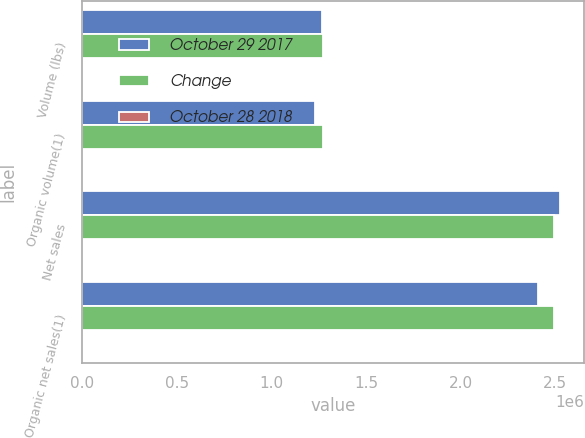<chart> <loc_0><loc_0><loc_500><loc_500><stacked_bar_chart><ecel><fcel>Volume (lbs)<fcel>Organic volume(1)<fcel>Net sales<fcel>Organic net sales(1)<nl><fcel>October 29 2017<fcel>1.26529e+06<fcel>1.23273e+06<fcel>2.5247e+06<fcel>2.4074e+06<nl><fcel>Change<fcel>1.27527e+06<fcel>1.27527e+06<fcel>2.49261e+06<fcel>2.49261e+06<nl><fcel>October 28 2018<fcel>0.8<fcel>3.3<fcel>1.3<fcel>3.4<nl></chart> 